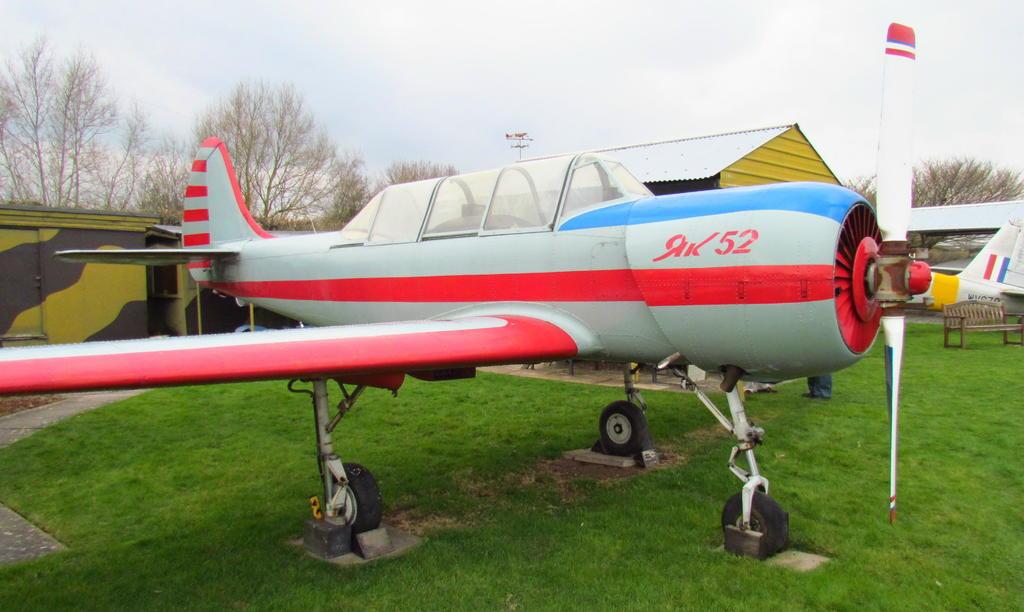What number is on the plane?
Provide a short and direct response. 52. 